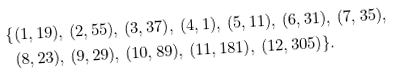<formula> <loc_0><loc_0><loc_500><loc_500>\{ & ( 1 , 1 9 ) , \, ( 2 , 5 5 ) , \, ( 3 , 3 7 ) , \, ( 4 , 1 ) , \, ( 5 , 1 1 ) , \, ( 6 , 3 1 ) , \, ( 7 , 3 5 ) , \\ & ( 8 , 2 3 ) , \, ( 9 , 2 9 ) , \, ( 1 0 , 8 9 ) , \, ( 1 1 , 1 8 1 ) , \, ( 1 2 , 3 0 5 ) \} .</formula> 